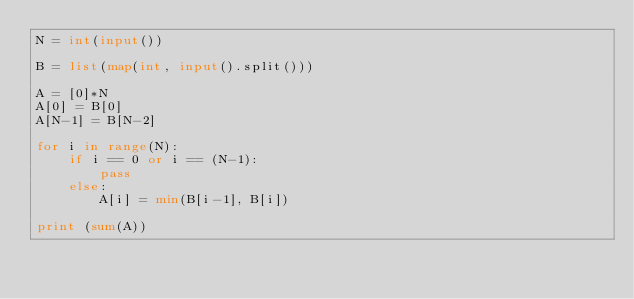Convert code to text. <code><loc_0><loc_0><loc_500><loc_500><_Python_>N = int(input())

B = list(map(int, input().split()))

A = [0]*N
A[0] = B[0]
A[N-1] = B[N-2]

for i in range(N):
    if i == 0 or i == (N-1):
        pass
    else:
        A[i] = min(B[i-1], B[i])

print (sum(A))</code> 